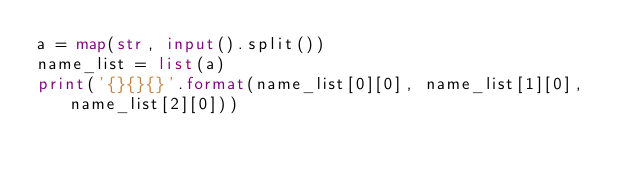<code> <loc_0><loc_0><loc_500><loc_500><_Python_>a = map(str, input().split())
name_list = list(a)
print('{}{}{}'.format(name_list[0][0], name_list[1][0], name_list[2][0]))</code> 